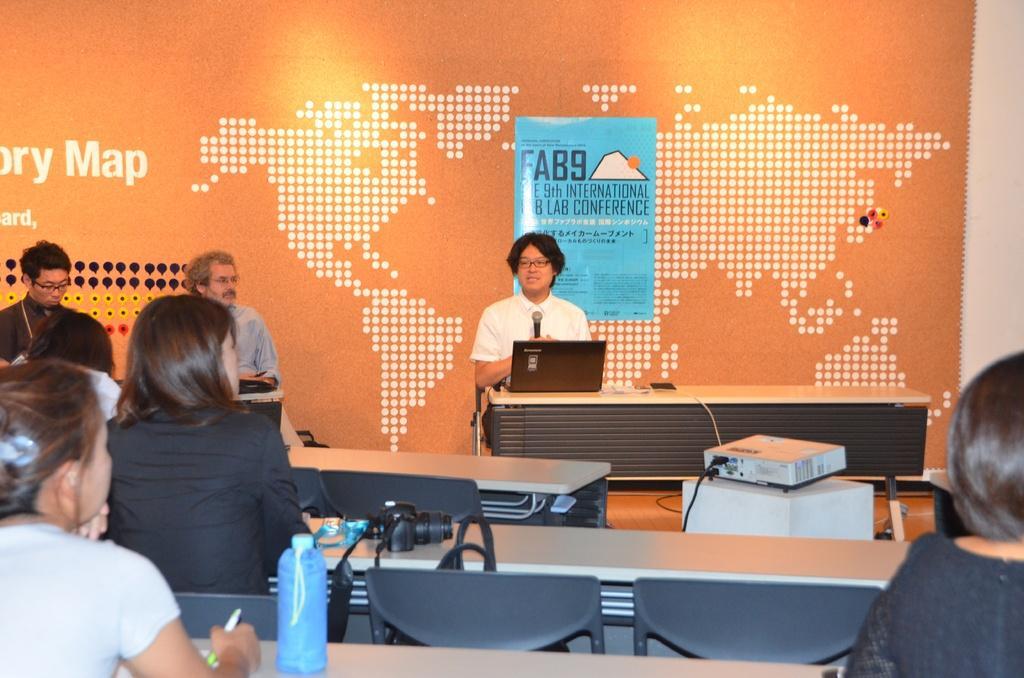Please provide a concise description of this image. In this image I can see few people are sitting on chairs. Here I can see a person is holding a mic and also I can see a laptop on this table. 